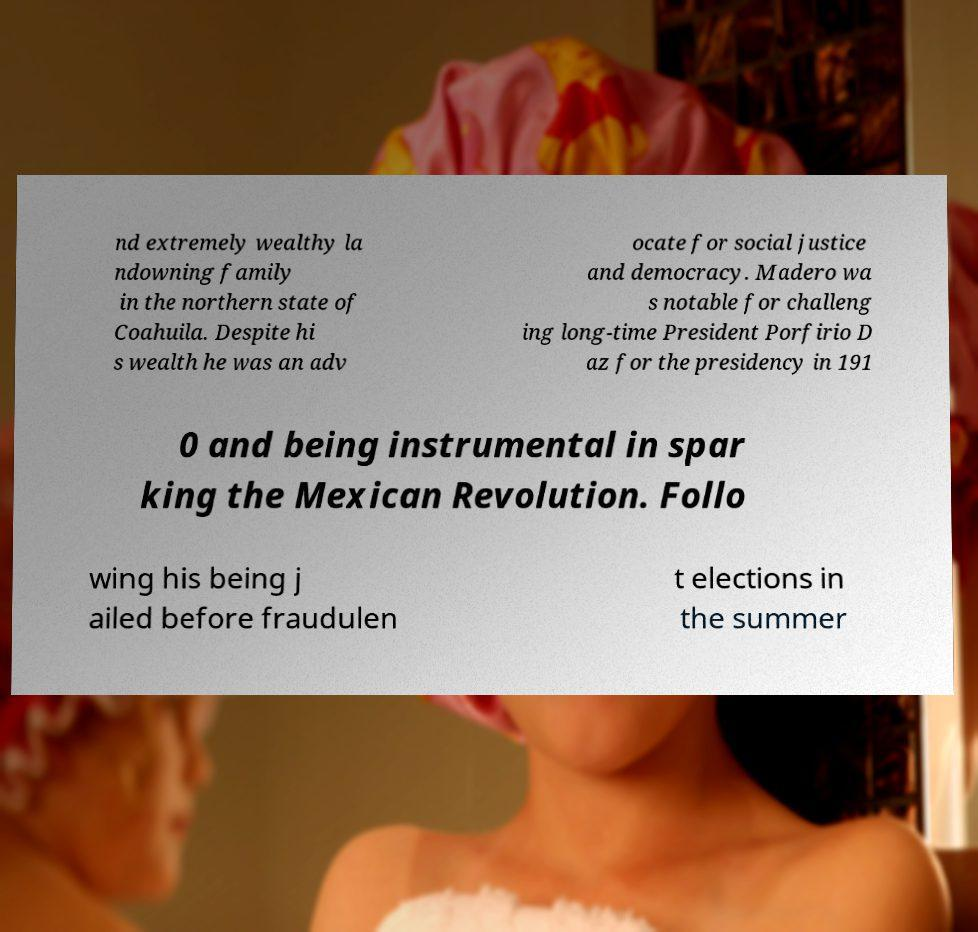What messages or text are displayed in this image? I need them in a readable, typed format. nd extremely wealthy la ndowning family in the northern state of Coahuila. Despite hi s wealth he was an adv ocate for social justice and democracy. Madero wa s notable for challeng ing long-time President Porfirio D az for the presidency in 191 0 and being instrumental in spar king the Mexican Revolution. Follo wing his being j ailed before fraudulen t elections in the summer 